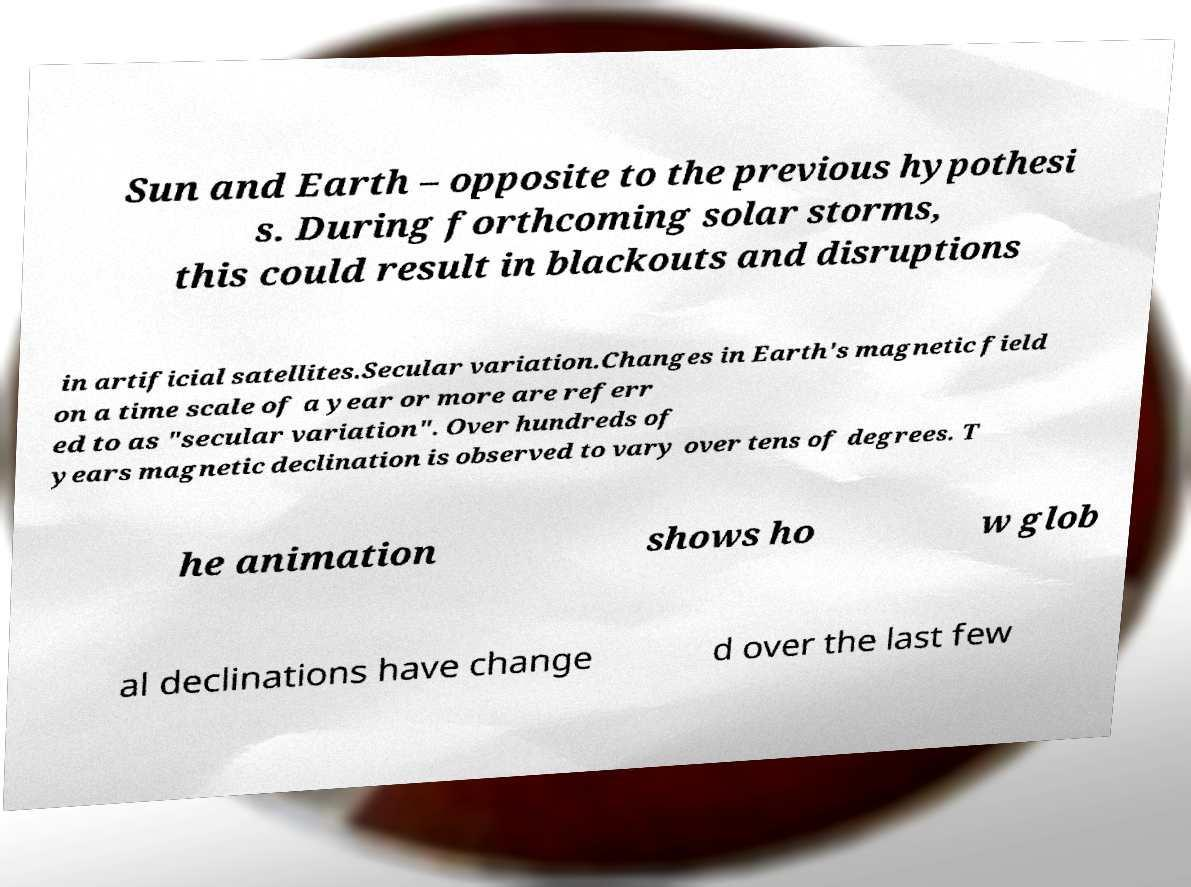Can you read and provide the text displayed in the image?This photo seems to have some interesting text. Can you extract and type it out for me? Sun and Earth – opposite to the previous hypothesi s. During forthcoming solar storms, this could result in blackouts and disruptions in artificial satellites.Secular variation.Changes in Earth's magnetic field on a time scale of a year or more are referr ed to as "secular variation". Over hundreds of years magnetic declination is observed to vary over tens of degrees. T he animation shows ho w glob al declinations have change d over the last few 